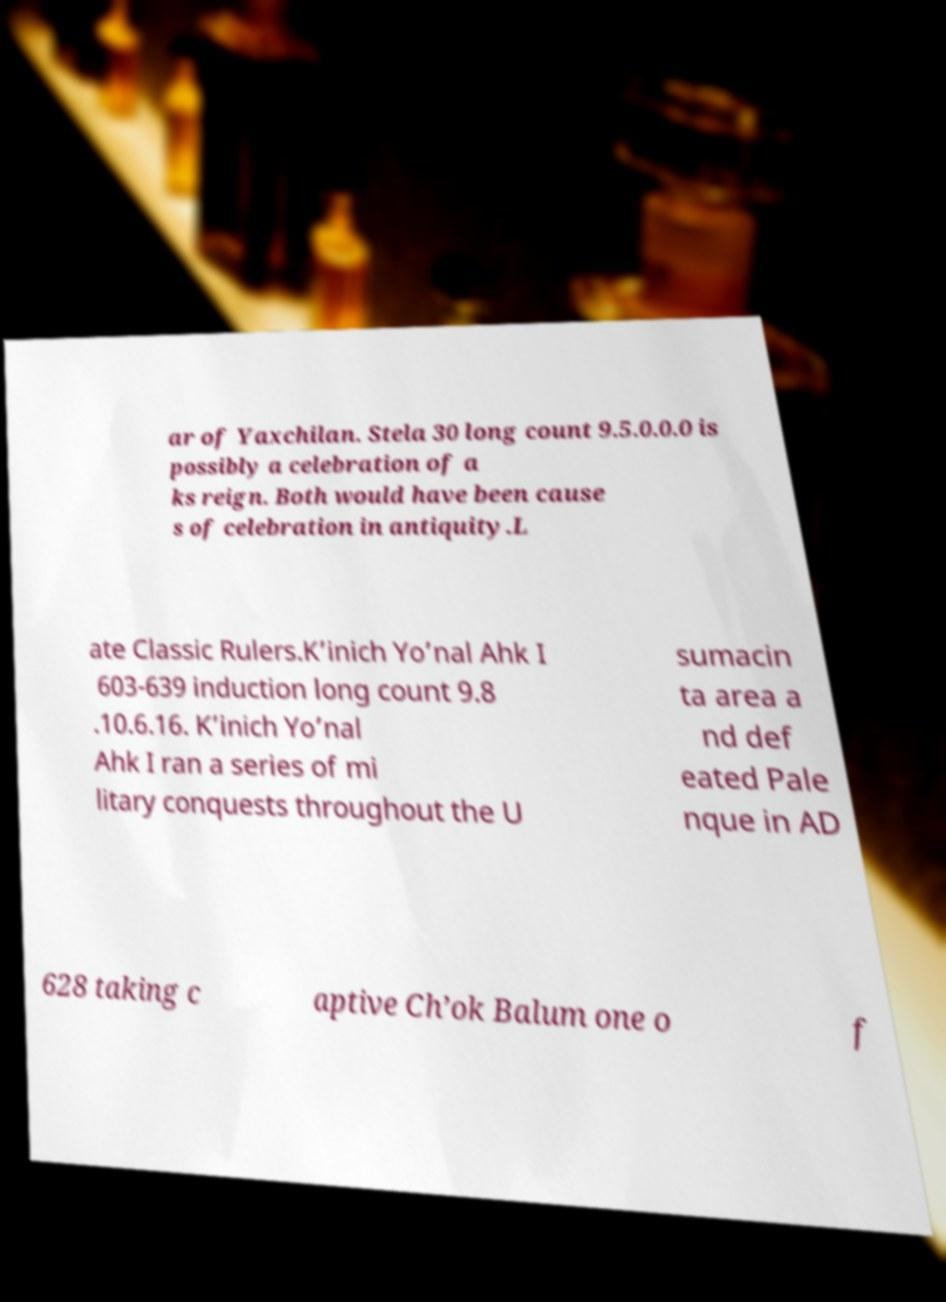Can you accurately transcribe the text from the provided image for me? ar of Yaxchilan. Stela 30 long count 9.5.0.0.0 is possibly a celebration of a ks reign. Both would have been cause s of celebration in antiquity.L ate Classic Rulers.K’inich Yo’nal Ahk I 603-639 induction long count 9.8 .10.6.16. K’inich Yo’nal Ahk I ran a series of mi litary conquests throughout the U sumacin ta area a nd def eated Pale nque in AD 628 taking c aptive Ch’ok Balum one o f 